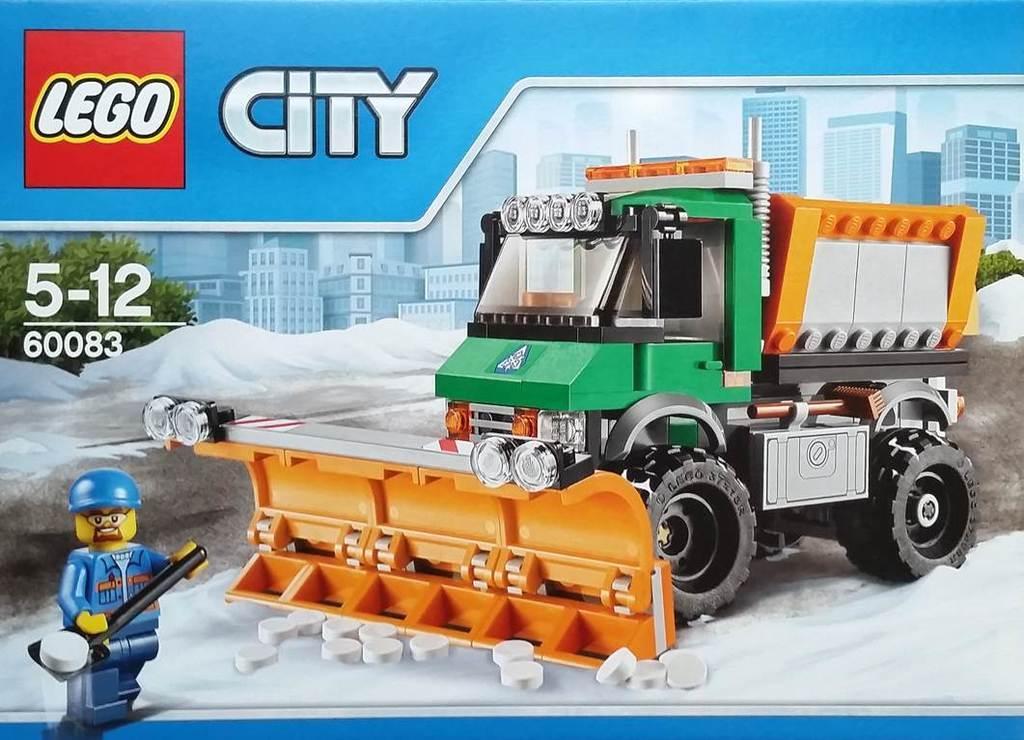Can you describe this image briefly? This is a poster. Here we can see a vehicle, buildings, trees, and a cartoon. 